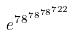Convert formula to latex. <formula><loc_0><loc_0><loc_500><loc_500>e ^ { 7 8 ^ { 7 8 ^ { 7 8 ^ { 7 2 2 } } } }</formula> 